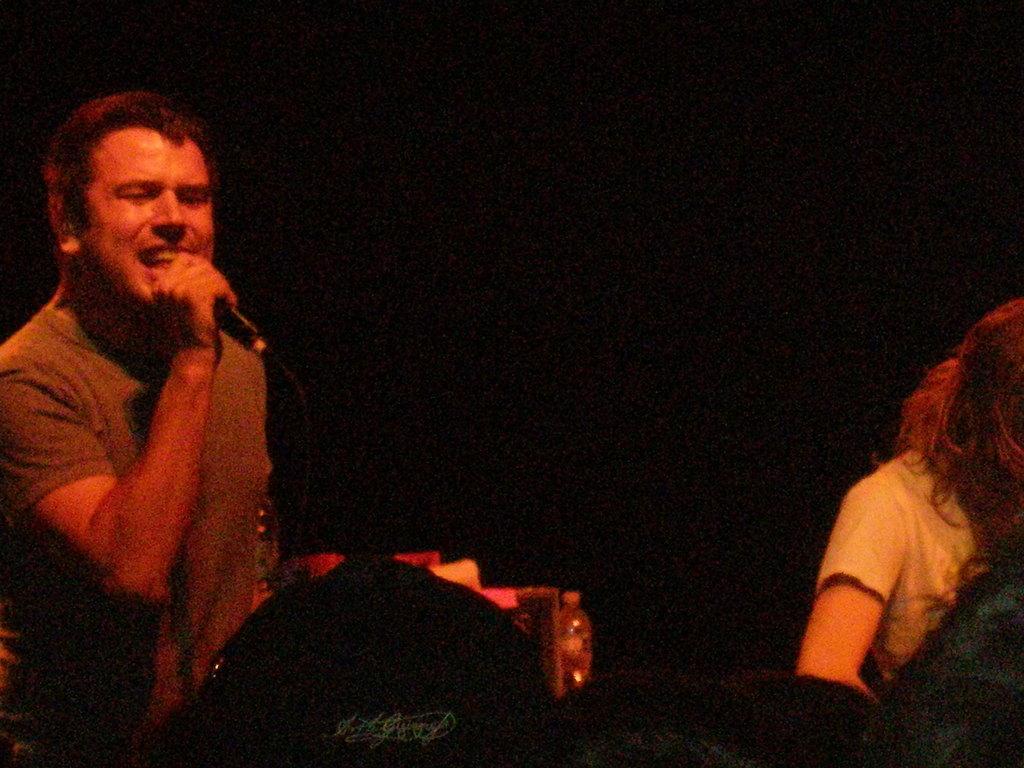Could you give a brief overview of what you see in this image? In this image I can see two persons and on the left side of this image I can see one of them is holding a mic. I can also see this image is little bit in dark. 